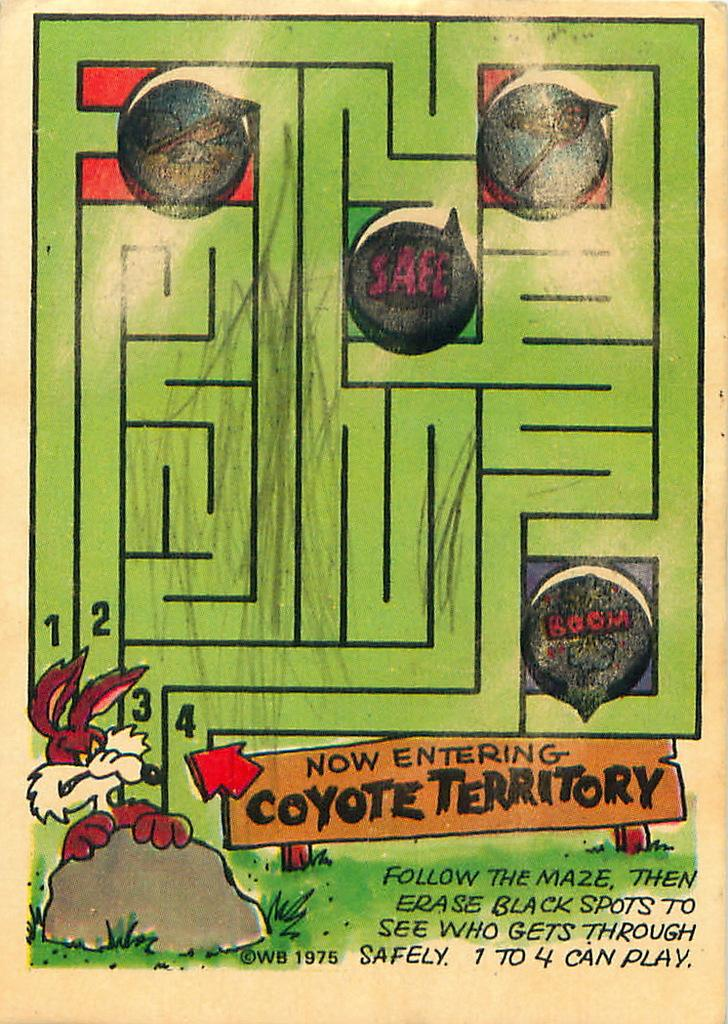What is present on the poster in the image? There is a poster in the image. What can be found on the poster besides the cartoons? There is text on the poster. How many trees are depicted on the poster? There is no mention of trees on the poster; it features text and cartoons. What type of emotion is being expressed by the cartoons on the poster? The provided facts do not mention any specific emotions being expressed by the cartoons on the poster. 